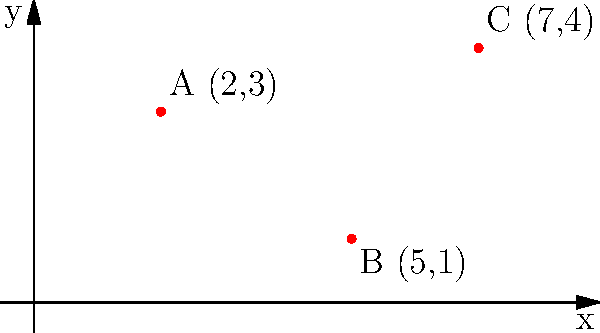As a former Sports Authority employee, you're consulting for a local gym on optimal basketball hoop placement. Given a coordinate grid system where each unit represents 5 feet, three potential locations for basketball hoops are marked: A(2,3), B(5,1), and C(7,4). To maximize court space utilization, which two locations should be chosen to have the greatest distance between them? To find the two locations with the greatest distance between them, we need to calculate the distance between each pair of points using the distance formula:

$d = \sqrt{(x_2-x_1)^2 + (y_2-y_1)^2}$

1. Distance between A and B:
   $d_{AB} = \sqrt{(5-2)^2 + (1-3)^2} = \sqrt{3^2 + (-2)^2} = \sqrt{9 + 4} = \sqrt{13} \approx 3.61$ units

2. Distance between A and C:
   $d_{AC} = \sqrt{(7-2)^2 + (4-3)^2} = \sqrt{5^2 + 1^2} = \sqrt{25 + 1} = \sqrt{26} \approx 5.10$ units

3. Distance between B and C:
   $d_{BC} = \sqrt{(7-5)^2 + (4-1)^2} = \sqrt{2^2 + 3^2} = \sqrt{4 + 9} = \sqrt{13} \approx 3.61$ units

The greatest distance is between points A and C, which is approximately 5.10 units.

Since each unit represents 5 feet, the actual distance between A and C is:
$5.10 \times 5 = 25.5$ feet

Therefore, to maximize court space utilization, the gym should place basketball hoops at locations A(2,3) and C(7,4).
Answer: A(2,3) and C(7,4) 